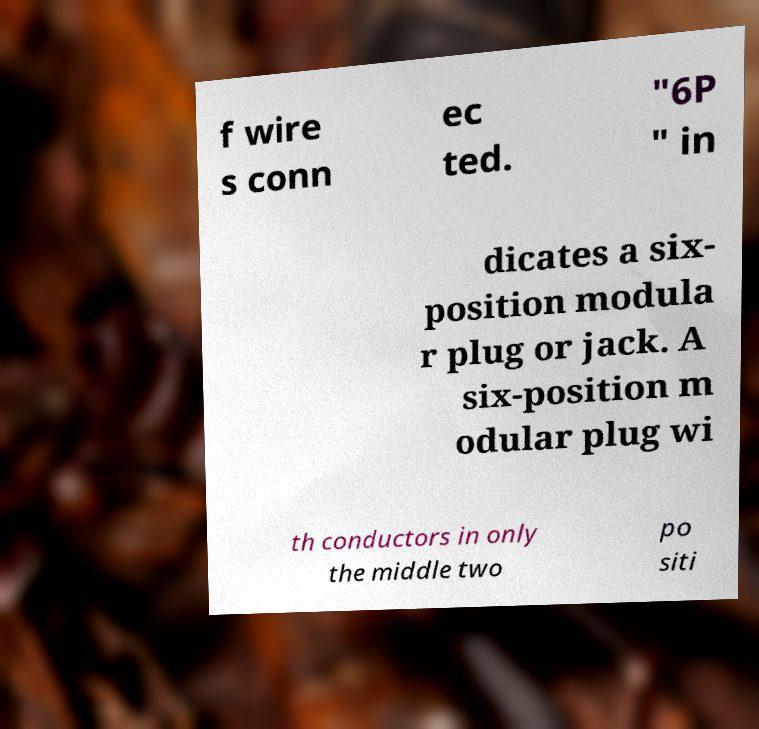Please read and relay the text visible in this image. What does it say? f wire s conn ec ted. "6P " in dicates a six- position modula r plug or jack. A six-position m odular plug wi th conductors in only the middle two po siti 